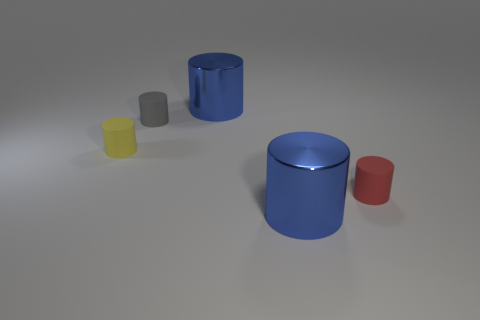Does the big metal object in front of the small yellow rubber thing have the same color as the shiny cylinder behind the tiny yellow cylinder?
Ensure brevity in your answer.  Yes. How many other objects are the same size as the gray cylinder?
Make the answer very short. 2. There is a large object in front of the large object behind the red rubber cylinder; what is it made of?
Provide a succinct answer. Metal. Are there fewer blue metallic objects left of the yellow rubber object than big gray rubber cylinders?
Keep it short and to the point. No. What is the color of the tiny cylinder on the right side of the blue metallic cylinder that is in front of the yellow rubber cylinder?
Your response must be concise. Red. There is a thing that is in front of the small red cylinder behind the blue metallic cylinder in front of the tiny red cylinder; how big is it?
Offer a terse response. Large. Are there fewer big things behind the small yellow cylinder than matte things that are to the left of the small red thing?
Give a very brief answer. Yes. What number of other things have the same material as the small gray thing?
Make the answer very short. 2. There is a blue shiny cylinder on the right side of the blue object that is behind the small yellow cylinder; are there any gray cylinders that are right of it?
Make the answer very short. No. There is a small gray object that is made of the same material as the small red cylinder; what is its shape?
Make the answer very short. Cylinder. 